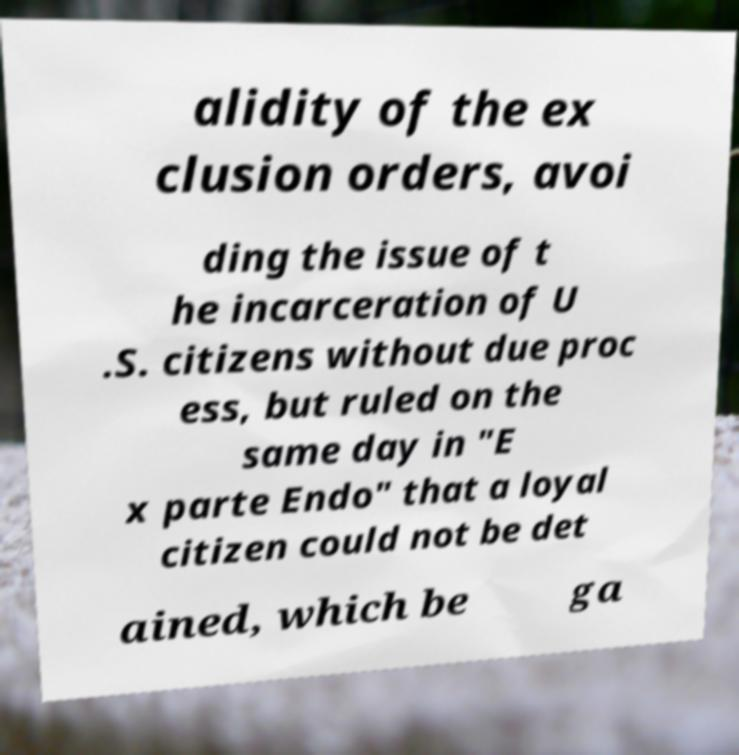Can you accurately transcribe the text from the provided image for me? alidity of the ex clusion orders, avoi ding the issue of t he incarceration of U .S. citizens without due proc ess, but ruled on the same day in "E x parte Endo" that a loyal citizen could not be det ained, which be ga 